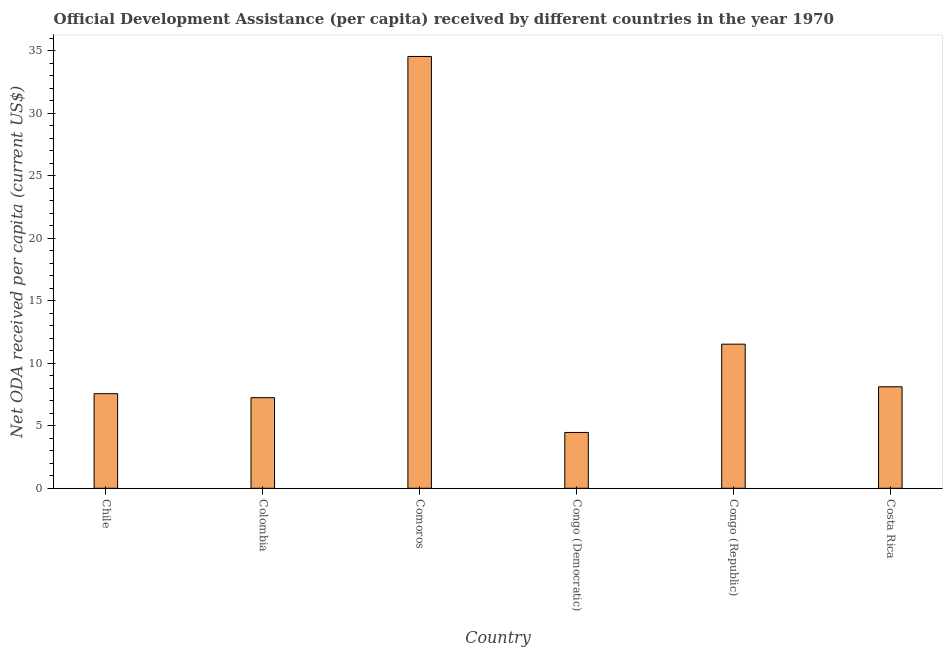Does the graph contain any zero values?
Provide a short and direct response. No. What is the title of the graph?
Offer a very short reply. Official Development Assistance (per capita) received by different countries in the year 1970. What is the label or title of the X-axis?
Your answer should be compact. Country. What is the label or title of the Y-axis?
Offer a very short reply. Net ODA received per capita (current US$). What is the net oda received per capita in Chile?
Provide a short and direct response. 7.57. Across all countries, what is the maximum net oda received per capita?
Make the answer very short. 34.54. Across all countries, what is the minimum net oda received per capita?
Make the answer very short. 4.47. In which country was the net oda received per capita maximum?
Provide a succinct answer. Comoros. In which country was the net oda received per capita minimum?
Provide a succinct answer. Congo (Democratic). What is the sum of the net oda received per capita?
Your answer should be compact. 73.46. What is the difference between the net oda received per capita in Chile and Colombia?
Your answer should be very brief. 0.32. What is the average net oda received per capita per country?
Keep it short and to the point. 12.24. What is the median net oda received per capita?
Make the answer very short. 7.84. In how many countries, is the net oda received per capita greater than 11 US$?
Your answer should be very brief. 2. What is the ratio of the net oda received per capita in Comoros to that in Congo (Republic)?
Offer a terse response. 3. Is the net oda received per capita in Comoros less than that in Congo (Republic)?
Keep it short and to the point. No. Is the difference between the net oda received per capita in Congo (Democratic) and Congo (Republic) greater than the difference between any two countries?
Give a very brief answer. No. What is the difference between the highest and the second highest net oda received per capita?
Your answer should be compact. 23.01. Is the sum of the net oda received per capita in Chile and Colombia greater than the maximum net oda received per capita across all countries?
Keep it short and to the point. No. What is the difference between the highest and the lowest net oda received per capita?
Your answer should be compact. 30.07. In how many countries, is the net oda received per capita greater than the average net oda received per capita taken over all countries?
Your answer should be compact. 1. How many countries are there in the graph?
Your answer should be very brief. 6. What is the difference between two consecutive major ticks on the Y-axis?
Offer a very short reply. 5. Are the values on the major ticks of Y-axis written in scientific E-notation?
Offer a very short reply. No. What is the Net ODA received per capita (current US$) in Chile?
Provide a short and direct response. 7.57. What is the Net ODA received per capita (current US$) of Colombia?
Your answer should be very brief. 7.25. What is the Net ODA received per capita (current US$) in Comoros?
Provide a succinct answer. 34.54. What is the Net ODA received per capita (current US$) in Congo (Democratic)?
Provide a short and direct response. 4.47. What is the Net ODA received per capita (current US$) of Congo (Republic)?
Keep it short and to the point. 11.53. What is the Net ODA received per capita (current US$) in Costa Rica?
Offer a terse response. 8.12. What is the difference between the Net ODA received per capita (current US$) in Chile and Colombia?
Your response must be concise. 0.32. What is the difference between the Net ODA received per capita (current US$) in Chile and Comoros?
Provide a succinct answer. -26.97. What is the difference between the Net ODA received per capita (current US$) in Chile and Congo (Democratic)?
Your answer should be compact. 3.1. What is the difference between the Net ODA received per capita (current US$) in Chile and Congo (Republic)?
Your answer should be very brief. -3.96. What is the difference between the Net ODA received per capita (current US$) in Chile and Costa Rica?
Your answer should be compact. -0.55. What is the difference between the Net ODA received per capita (current US$) in Colombia and Comoros?
Your response must be concise. -27.29. What is the difference between the Net ODA received per capita (current US$) in Colombia and Congo (Democratic)?
Offer a terse response. 2.78. What is the difference between the Net ODA received per capita (current US$) in Colombia and Congo (Republic)?
Provide a short and direct response. -4.28. What is the difference between the Net ODA received per capita (current US$) in Colombia and Costa Rica?
Give a very brief answer. -0.87. What is the difference between the Net ODA received per capita (current US$) in Comoros and Congo (Democratic)?
Your response must be concise. 30.07. What is the difference between the Net ODA received per capita (current US$) in Comoros and Congo (Republic)?
Your answer should be very brief. 23.01. What is the difference between the Net ODA received per capita (current US$) in Comoros and Costa Rica?
Your answer should be compact. 26.42. What is the difference between the Net ODA received per capita (current US$) in Congo (Democratic) and Congo (Republic)?
Your answer should be compact. -7.06. What is the difference between the Net ODA received per capita (current US$) in Congo (Democratic) and Costa Rica?
Your response must be concise. -3.65. What is the difference between the Net ODA received per capita (current US$) in Congo (Republic) and Costa Rica?
Make the answer very short. 3.41. What is the ratio of the Net ODA received per capita (current US$) in Chile to that in Colombia?
Offer a very short reply. 1.04. What is the ratio of the Net ODA received per capita (current US$) in Chile to that in Comoros?
Provide a short and direct response. 0.22. What is the ratio of the Net ODA received per capita (current US$) in Chile to that in Congo (Democratic)?
Offer a terse response. 1.7. What is the ratio of the Net ODA received per capita (current US$) in Chile to that in Congo (Republic)?
Your answer should be very brief. 0.66. What is the ratio of the Net ODA received per capita (current US$) in Chile to that in Costa Rica?
Ensure brevity in your answer.  0.93. What is the ratio of the Net ODA received per capita (current US$) in Colombia to that in Comoros?
Give a very brief answer. 0.21. What is the ratio of the Net ODA received per capita (current US$) in Colombia to that in Congo (Democratic)?
Give a very brief answer. 1.62. What is the ratio of the Net ODA received per capita (current US$) in Colombia to that in Congo (Republic)?
Keep it short and to the point. 0.63. What is the ratio of the Net ODA received per capita (current US$) in Colombia to that in Costa Rica?
Keep it short and to the point. 0.89. What is the ratio of the Net ODA received per capita (current US$) in Comoros to that in Congo (Democratic)?
Give a very brief answer. 7.73. What is the ratio of the Net ODA received per capita (current US$) in Comoros to that in Congo (Republic)?
Your response must be concise. 3. What is the ratio of the Net ODA received per capita (current US$) in Comoros to that in Costa Rica?
Give a very brief answer. 4.25. What is the ratio of the Net ODA received per capita (current US$) in Congo (Democratic) to that in Congo (Republic)?
Keep it short and to the point. 0.39. What is the ratio of the Net ODA received per capita (current US$) in Congo (Democratic) to that in Costa Rica?
Your response must be concise. 0.55. What is the ratio of the Net ODA received per capita (current US$) in Congo (Republic) to that in Costa Rica?
Provide a succinct answer. 1.42. 